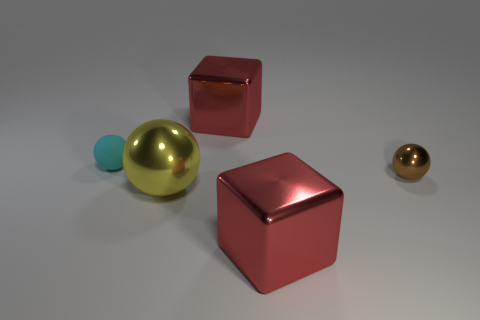How many tiny brown spheres are in front of the yellow metallic sphere?
Your response must be concise. 0. There is a big red object behind the yellow thing; is it the same shape as the brown shiny thing?
Offer a terse response. No. Is there a red thing of the same shape as the tiny brown shiny object?
Provide a short and direct response. No. What is the shape of the red shiny object that is in front of the red cube that is behind the big yellow object?
Give a very brief answer. Cube. What number of other brown spheres are made of the same material as the tiny brown sphere?
Your answer should be compact. 0. There is a tiny thing that is the same material as the large yellow ball; what color is it?
Keep it short and to the point. Brown. How big is the red shiny block that is in front of the small cyan object to the left of the tiny thing that is to the right of the tiny cyan ball?
Provide a succinct answer. Large. Is the number of yellow things less than the number of small green shiny objects?
Provide a short and direct response. No. There is a tiny rubber thing that is the same shape as the yellow metallic thing; what is its color?
Offer a very short reply. Cyan. There is a big object on the left side of the big red cube that is behind the yellow object; are there any large metallic spheres to the left of it?
Give a very brief answer. No. 